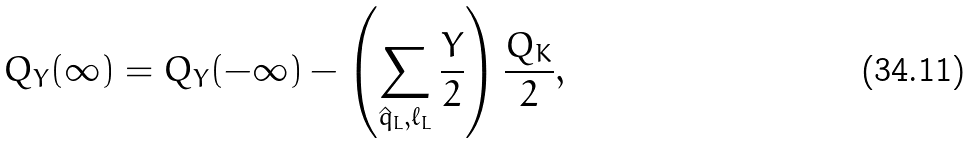Convert formula to latex. <formula><loc_0><loc_0><loc_500><loc_500>Q _ { Y } ( \infty ) = Q _ { Y } ( - \infty ) - \left ( \sum _ { \hat { q } _ { L } , \ell _ { L } } \frac { Y } { 2 } \right ) \frac { Q _ { K } } { 2 } ,</formula> 